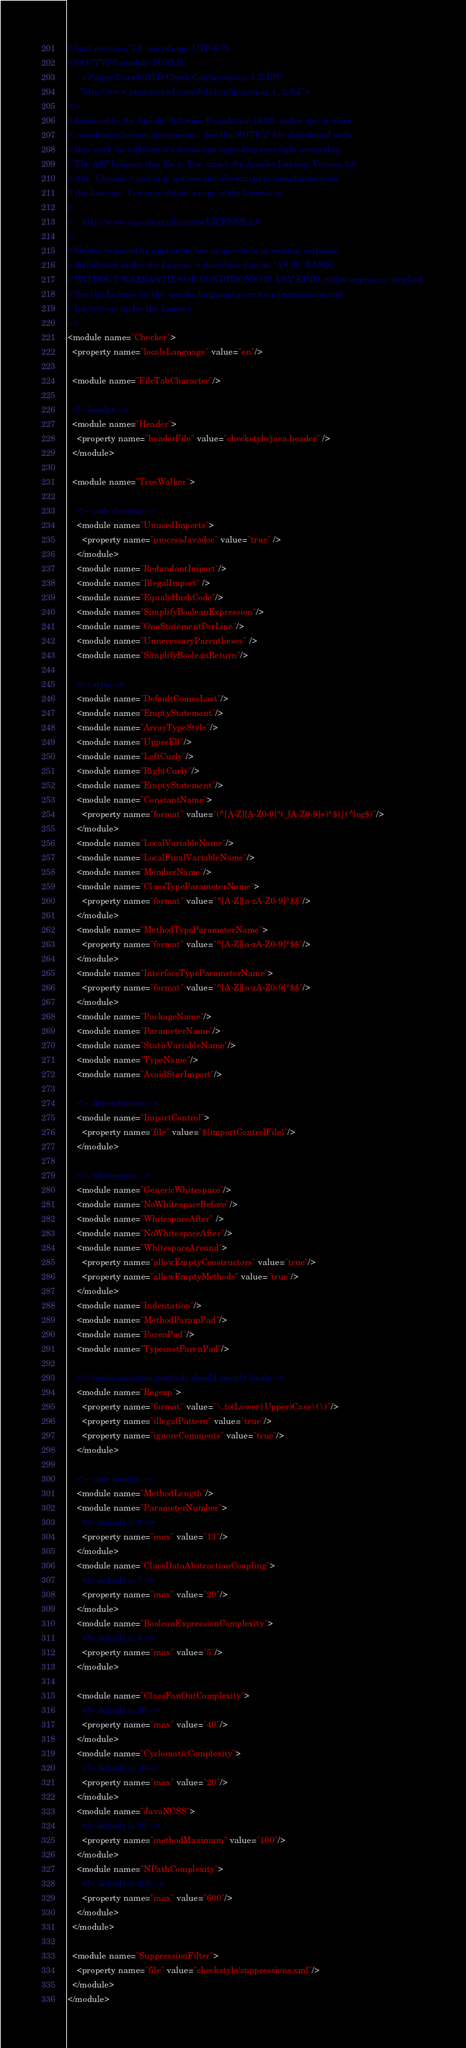Convert code to text. <code><loc_0><loc_0><loc_500><loc_500><_XML_><?xml version="1.0" encoding="UTF-8"?>
<!DOCTYPE module PUBLIC
    "-//Puppy Crawl//DTD Check Configuration 1.3//EN"
     "http://www.puppycrawl.com/dtds/configuration_1_3.dtd">
<!--
// Licensed to the Apache Software Foundation (ASF) under one or more
// contributor license agreements.  See the NOTICE file distributed with
// this work for additional information regarding copyright ownership.
// The ASF licenses this file to You under the Apache License, Version 2.0
// (the "License"); you may not use this file except in compliance with
// the License.  You may obtain a copy of the License at
//
//    http://www.apache.org/licenses/LICENSE-2.0
//
// Unless required by applicable law or agreed to in writing, software
// distributed under the License is distributed on an "AS IS" BASIS,
// WITHOUT WARRANTIES OR CONDITIONS OF ANY KIND, either express or implied.
// See the License for the specific language governing permissions and
// limitations under the License.
-->
<module name="Checker">
  <property name="localeLanguage" value="en"/>

  <module name="FileTabCharacter"/>

  <!-- header -->
  <module name="Header">
    <property name="headerFile" value="checkstyle/java.header" />
  </module>

  <module name="TreeWalker">

    <!-- code cleanup -->
    <module name="UnusedImports">
      <property name="processJavadoc" value="true" />
    </module>
    <module name="RedundantImport"/>
    <module name="IllegalImport" />
    <module name="EqualsHashCode"/>
    <module name="SimplifyBooleanExpression"/>
    <module name="OneStatementPerLine"/>
    <module name="UnnecessaryParentheses" />
    <module name="SimplifyBooleanReturn"/>

    <!-- style -->
    <module name="DefaultComesLast"/>
    <module name="EmptyStatement"/>
    <module name="ArrayTypeStyle"/>
    <module name="UpperEll"/>
    <module name="LeftCurly"/>
    <module name="RightCurly"/>
    <module name="EmptyStatement"/>
    <module name="ConstantName">
      <property name="format" value="(^[A-Z][A-Z0-9]*(_[A-Z0-9]+)*$)|(^log$)"/>
    </module>
    <module name="LocalVariableName"/>
    <module name="LocalFinalVariableName"/>
    <module name="MemberName"/>
    <module name="ClassTypeParameterName">
      <property name="format" value="^[A-Z][a-zA-Z0-9]*$$"/>
    </module>
    <module name="MethodTypeParameterName">
      <property name="format" value="^[A-Z][a-zA-Z0-9]*$$"/>
    </module>
    <module name="InterfaceTypeParameterName">
      <property name="format" value="^[A-Z][a-zA-Z0-9]*$$"/>
    </module>
    <module name="PackageName"/>
    <module name="ParameterName"/>
    <module name="StaticVariableName"/>
    <module name="TypeName"/>
    <module name="AvoidStarImport"/>

    <!-- dependencies -->
    <module name="ImportControl">
      <property name="file" value="${importControlFile}"/>
    </module>

    <!-- whitespace -->
    <module name="GenericWhitespace"/>
    <module name="NoWhitespaceBefore"/>
    <module name="WhitespaceAfter" />
    <module name="NoWhitespaceAfter"/>
    <module name="WhitespaceAround">
      <property name="allowEmptyConstructors" value="true"/>
      <property name="allowEmptyMethods" value="true"/>
    </module>
    <module name="Indentation"/>
    <module name="MethodParamPad"/>
    <module name="ParenPad"/>
    <module name="TypecastParenPad"/>

    <!-- locale-sensitive methods should specify locale -->
    <module name="Regexp">
      <property name="format" value="\.to(Lower|Upper)Case\(\)"/>
      <property name="illegalPattern" value="true"/>
      <property name="ignoreComments" value="true"/>
    </module>

    <!-- code quality -->
    <module name="MethodLength"/>
    <module name="ParameterNumber">
      <!-- default is 8 -->
      <property name="max" value="13"/>
    </module>
    <module name="ClassDataAbstractionCoupling">
      <!-- default is 7 -->
      <property name="max" value="20"/>
    </module>
    <module name="BooleanExpressionComplexity">
      <!-- default is 3 -->
      <property name="max" value="5"/>
    </module>

    <module name="ClassFanOutComplexity">
      <!-- default is 20 -->
      <property name="max" value="40"/>
    </module>
    <module name="CyclomaticComplexity">
      <!-- default is 10-->
      <property name="max" value="20"/>
    </module>
    <module name="JavaNCSS">
      <!-- default is 50 -->
      <property name="methodMaximum" value="100"/>
    </module>
    <module name="NPathComplexity">
      <!-- default is 200 -->
      <property name="max" value="600"/>
    </module>
  </module>

  <module name="SuppressionFilter">
    <property name="file" value="checkstyle/suppressions.xml"/>
  </module>
</module>
</code> 